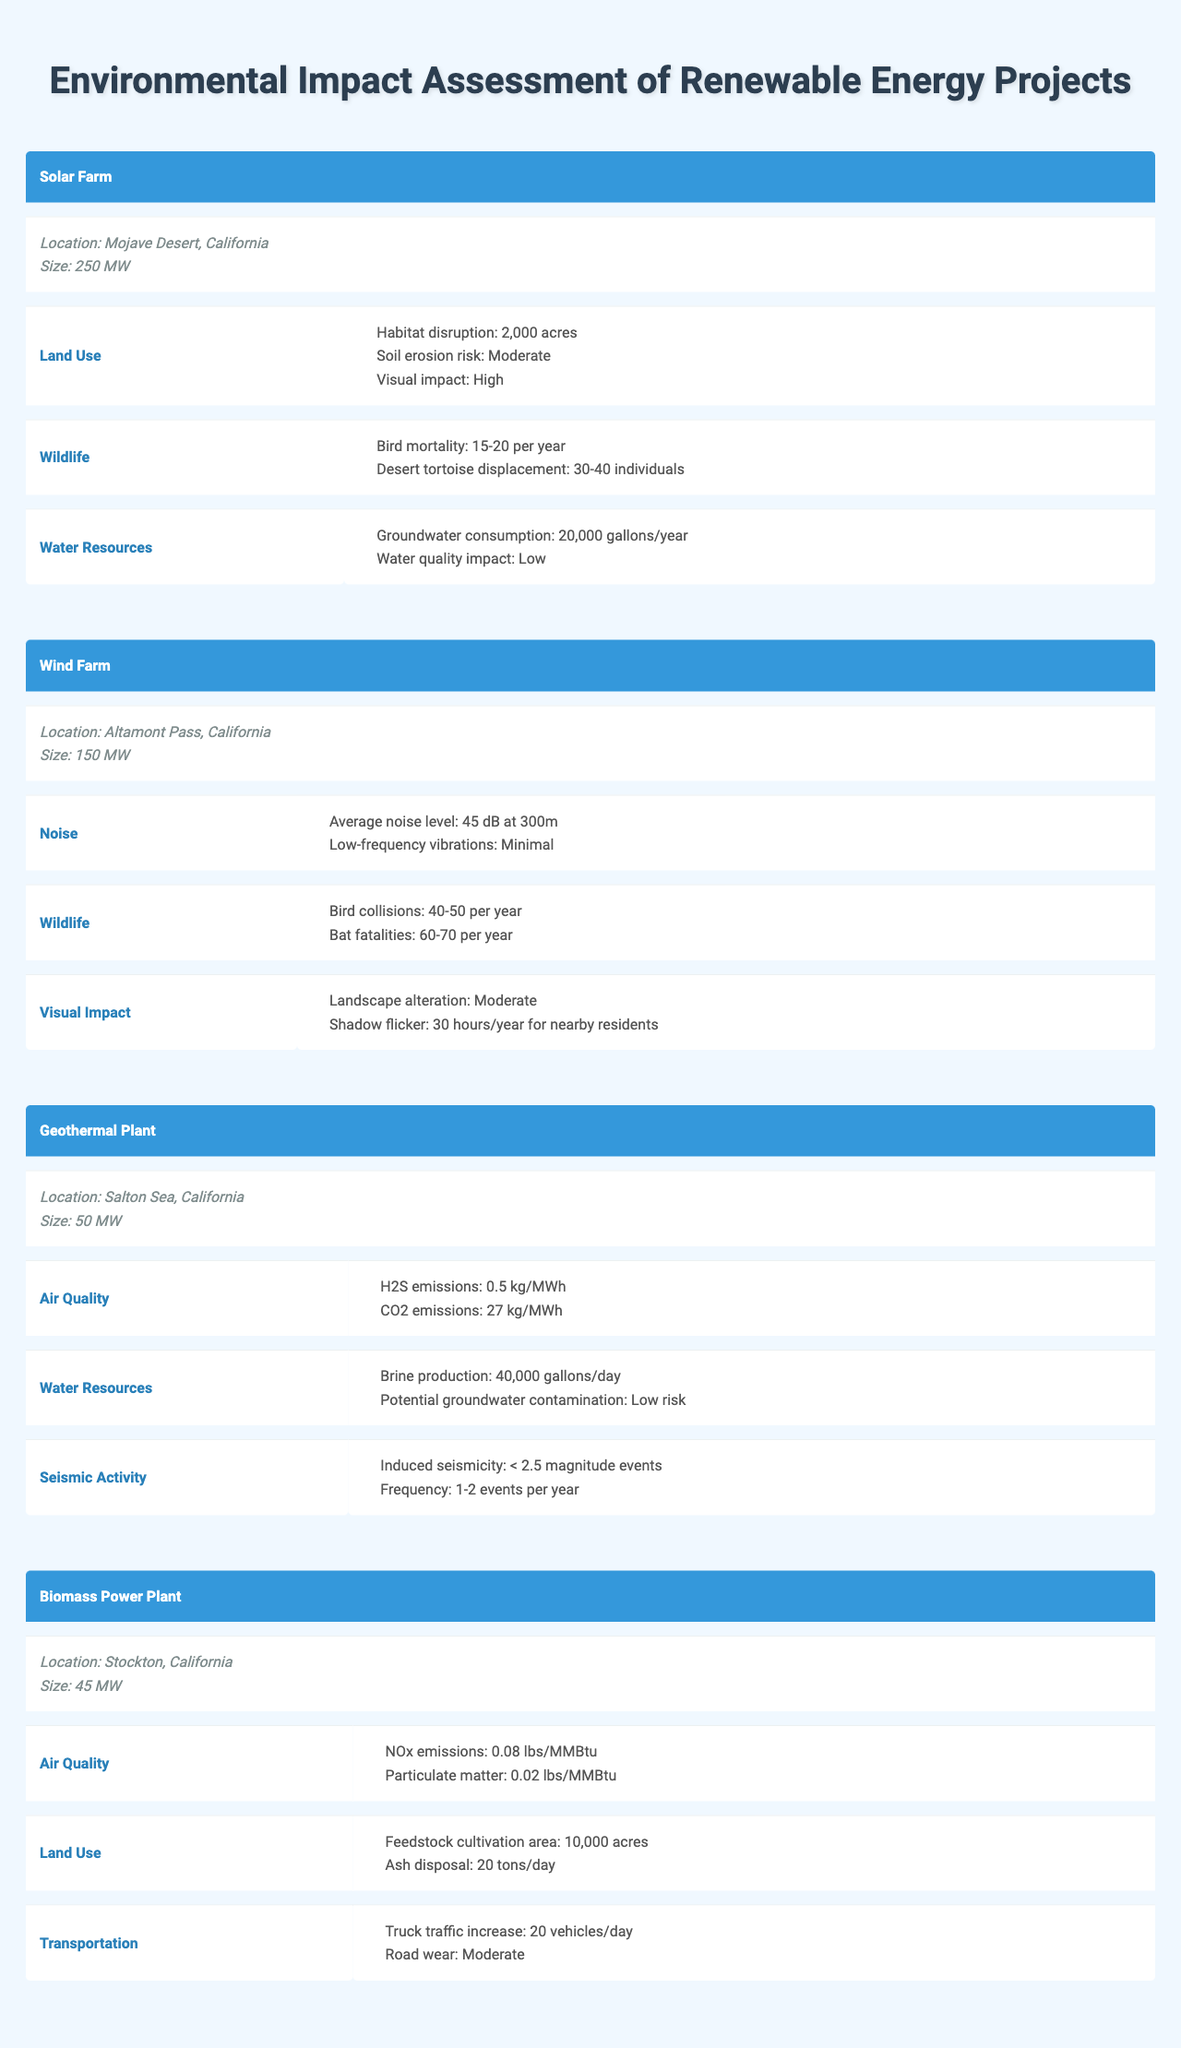What is the location of the Solar Farm project? The Solar Farm project is located in the Mojave Desert, California, as stated in the table under the location column.
Answer: Mojave Desert, California How many acres are disrupted by the Solar Farm project? The table mentions that the Solar Farm project has a habitat disruption of 2,000 acres in the land use impacts section.
Answer: 2,000 acres What is the average number of bird casualties per year for the Wind Farm project? The table states that the Wind Farm project leads to 40-50 bird collisions per year. The average, therefore, can be calculated as (40 + 50) / 2 = 45 per year.
Answer: 45 Is the visual impact of the Solar Farm project rated as high? According to the impacts listed for the Solar Farm, the visual impact effect is categorized as high, confirming that the statement is true.
Answer: Yes Which project has the highest groundwater consumption? The table shows that the Geothermal Plant project has brine production of 40,000 gallons/day, while the Solar Farm has groundwater consumption of 20,000 gallons/year. To compare, we convert 20,000 gallons/year to daily consumption (20,000 / 365 ≈ 54.79 gallons/day), indicating that the Geothermal Plant's 40,000 gallons/day is higher.
Answer: Geothermal Plant What is the total NOx emissions from the Biomass Power Plant project? The Biomass Power Plant project emits 0.08 lbs/MMBtu, but since no specific total is provided in the table, we cannot determine a total emission number without additional information about energy production.
Answer: Not specified How many bat fatalities are estimated per year at the Wind Farm project? According to the impacts for wildlife detailed in the table, the Wind Farm project leads to 60-70 bat fatalities each year. The estimate indicates a range, so an average could be taken but is not required for a direct answer.
Answer: 60-70 per year Which renewable energy project has the lowest seismic activity risk? The Geothermal Plant mentions induced seismicity of < 2.5 magnitude events with a frequency of 1-2 events per year, while other projects do not mention seismic activity. Thus, it can be inferred that this project has a defined but low risk compared to none in others.
Answer: Geothermal Plant What is the truck traffic increase per day for the Biomass Power Plant? The table lists the truck traffic increase for the Biomass Power Plant as 20 vehicles/day, which can be directly retrieved from the transportation impacts section.
Answer: 20 vehicles/day Which project's air quality impact has the highest emissions? The air quality impacts for the Biomass Power Plant include NOx emissions of 0.08 lbs/MMBtu and particulate matter of 0.02 lbs/MMBtu, while the Geothermal Plant has H2S emissions of 0.5 kg/MWh and CO2 emissions of 27 kg/MWh. To determine which contributes higher emissions requires more context about energy output; however, the Geothermal Plant suggests heavier emissions based on CO2 levels, which are of more concern than NOx here.
Answer: Geothermal Plant 